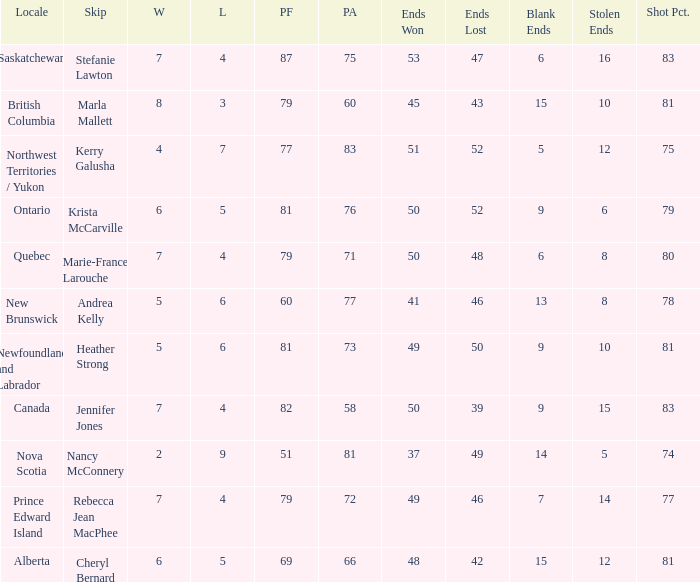Where was the shot pct 78? New Brunswick. 